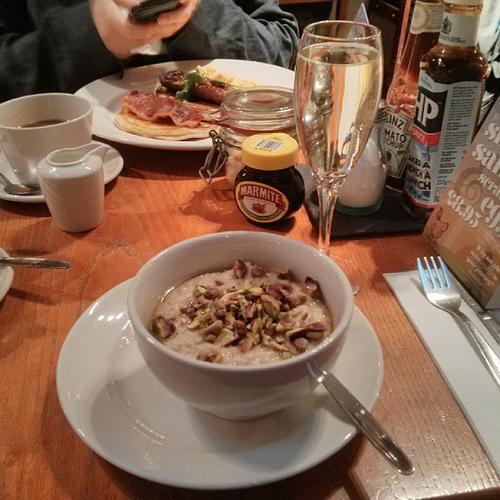How many glasses are on the table?
Give a very brief answer. 1. 